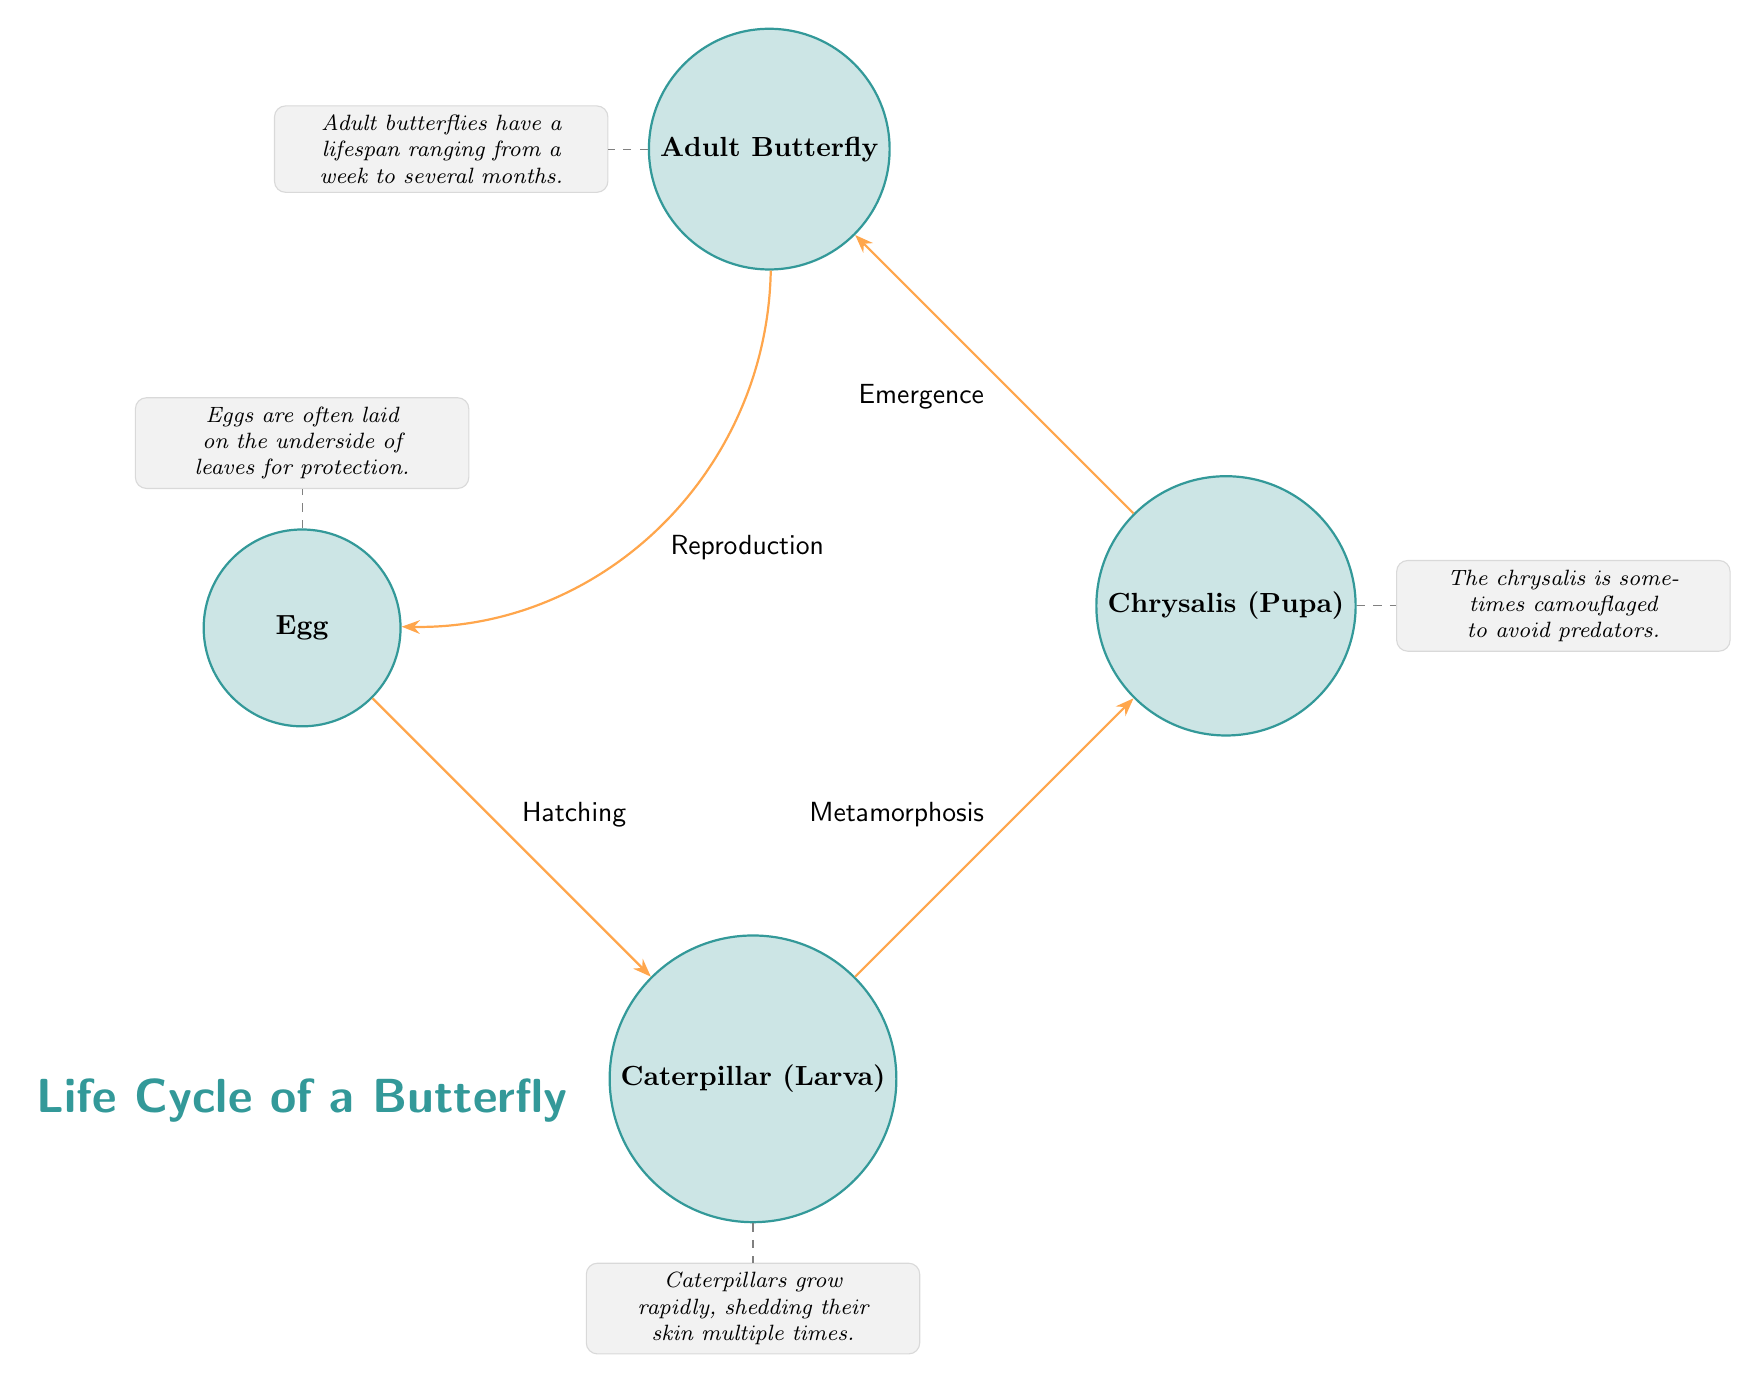What are the four stages shown in the diagram? The diagram clearly displays four distinct stages: Egg, Caterpillar (Larva), Chrysalis (Pupa), and Adult Butterfly.
Answer: Egg, Caterpillar (Larva), Chrysalis (Pupa), Adult Butterfly What is the transition from Caterpillar to Chrysalis called? The diagram indicates that the transition between the Caterpillar and Chrysalis stages is labeled as "Metamorphosis."
Answer: Metamorphosis How many annotations are there in the diagram? There are four annotated notes corresponding to each stage in the life cycle, which are: Egg, Caterpillar, Chrysalis, and Butterfly.
Answer: 4 What is the lifespan of an Adult Butterfly? The annotation for the Adult Butterfly stage mentions that its lifespan can range from a week to several months.
Answer: A week to several months Which stage comes before the Adult Butterfly? According to the flow in the diagram, the stage that comes immediately before the Adult Butterfly is the Chrysalis (Pupa).
Answer: Chrysalis (Pupa) Which stage has the note about camouflage? The diagram includes an annotation related to camouflage for the Chrysalis stage, indicating that it is sometimes camouflaged to avoid predators.
Answer: Chrysalis What is the first transition in the life cycle? The first transition in the diagram proceeds from the Egg to the Caterpillar, which is labeled as "Hatching."
Answer: Hatching During which stage does shedding skin occur? The annotation for the Caterpillar stage specifies that caterpillars grow rapidly and shed their skin multiple times during this stage.
Answer: Caterpillar (Larva) 